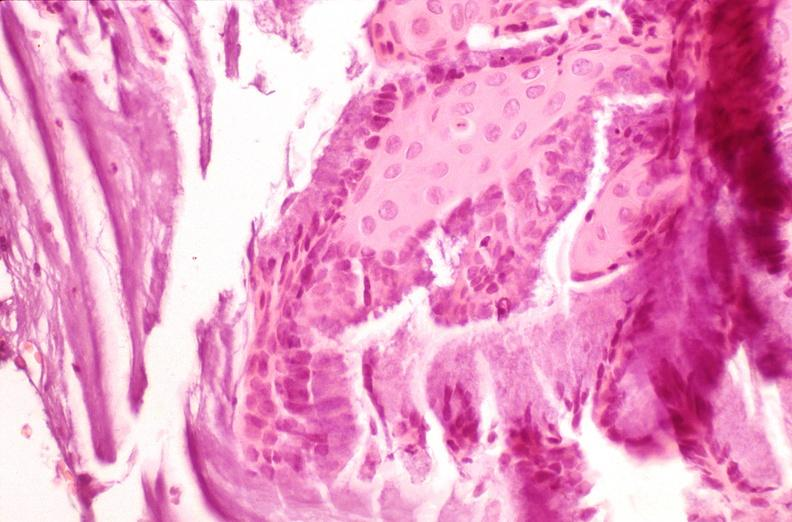does this image show cervix, squamous metaplasia?
Answer the question using a single word or phrase. Yes 